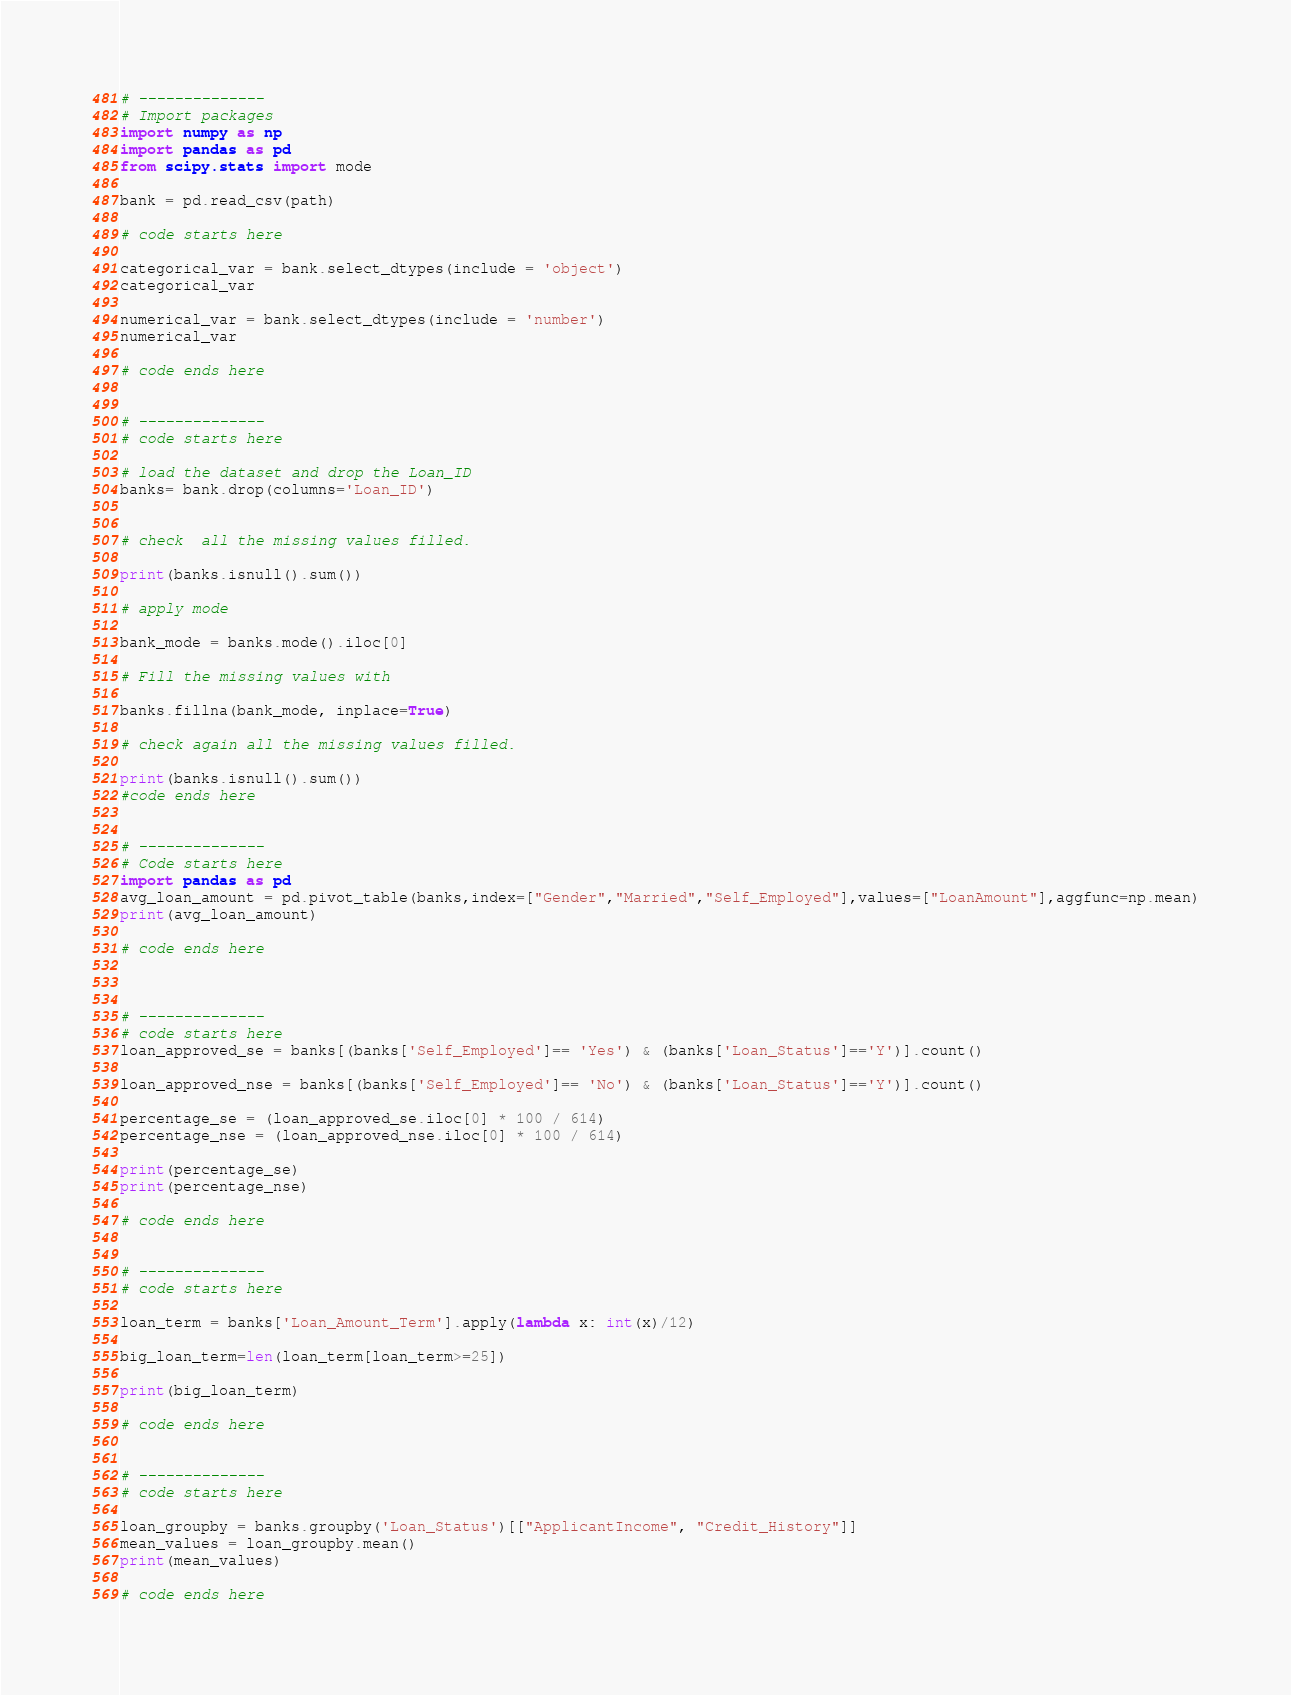Convert code to text. <code><loc_0><loc_0><loc_500><loc_500><_Python_># --------------
# Import packages
import numpy as np
import pandas as pd
from scipy.stats import mode 
 
bank = pd.read_csv(path)

# code starts here

categorical_var = bank.select_dtypes(include = 'object')
categorical_var

numerical_var = bank.select_dtypes(include = 'number')
numerical_var

# code ends here


# --------------
# code starts here

# load the dataset and drop the Loan_ID
banks= bank.drop(columns='Loan_ID')


# check  all the missing values filled.

print(banks.isnull().sum())

# apply mode 

bank_mode = banks.mode().iloc[0]

# Fill the missing values with 

banks.fillna(bank_mode, inplace=True)

# check again all the missing values filled.

print(banks.isnull().sum())
#code ends here


# --------------
# Code starts here
import pandas as pd
avg_loan_amount = pd.pivot_table(banks,index=["Gender","Married","Self_Employed"],values=["LoanAmount"],aggfunc=np.mean)
print(avg_loan_amount)

# code ends here



# --------------
# code starts here
loan_approved_se = banks[(banks['Self_Employed']== 'Yes') & (banks['Loan_Status']=='Y')].count()

loan_approved_nse = banks[(banks['Self_Employed']== 'No') & (banks['Loan_Status']=='Y')].count()

percentage_se = (loan_approved_se.iloc[0] * 100 / 614)
percentage_nse = (loan_approved_nse.iloc[0] * 100 / 614)

print(percentage_se)
print(percentage_nse)

# code ends here


# --------------
# code starts here

loan_term = banks['Loan_Amount_Term'].apply(lambda x: int(x)/12)

big_loan_term=len(loan_term[loan_term>=25])

print(big_loan_term)

# code ends here


# --------------
# code starts here

loan_groupby = banks.groupby('Loan_Status')[["ApplicantIncome", "Credit_History"]]
mean_values = loan_groupby.mean()
print(mean_values)

# code ends here


</code> 